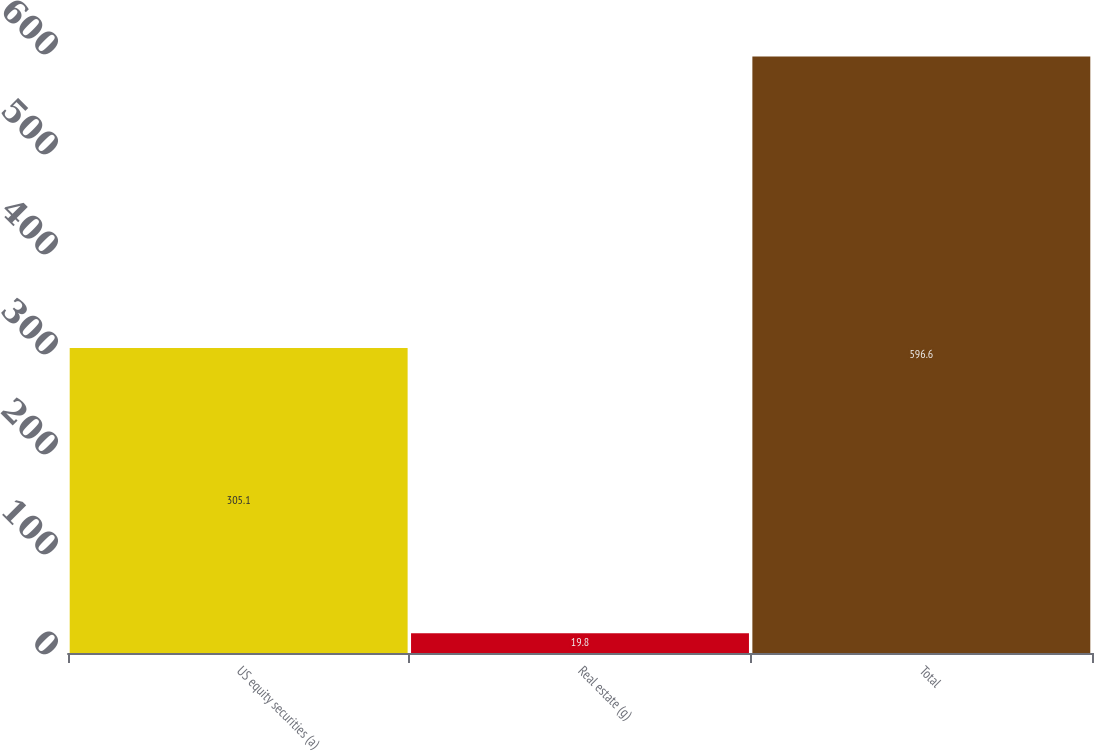Convert chart to OTSL. <chart><loc_0><loc_0><loc_500><loc_500><bar_chart><fcel>US equity securities (a)<fcel>Real estate (g)<fcel>Total<nl><fcel>305.1<fcel>19.8<fcel>596.6<nl></chart> 